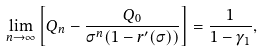<formula> <loc_0><loc_0><loc_500><loc_500>\lim _ { n \to \infty } \left [ Q _ { n } - \frac { Q _ { 0 } } { \sigma ^ { n } ( 1 - r ^ { \prime } ( \sigma ) ) } \right ] = \frac { 1 } { 1 - \gamma _ { 1 } } ,</formula> 